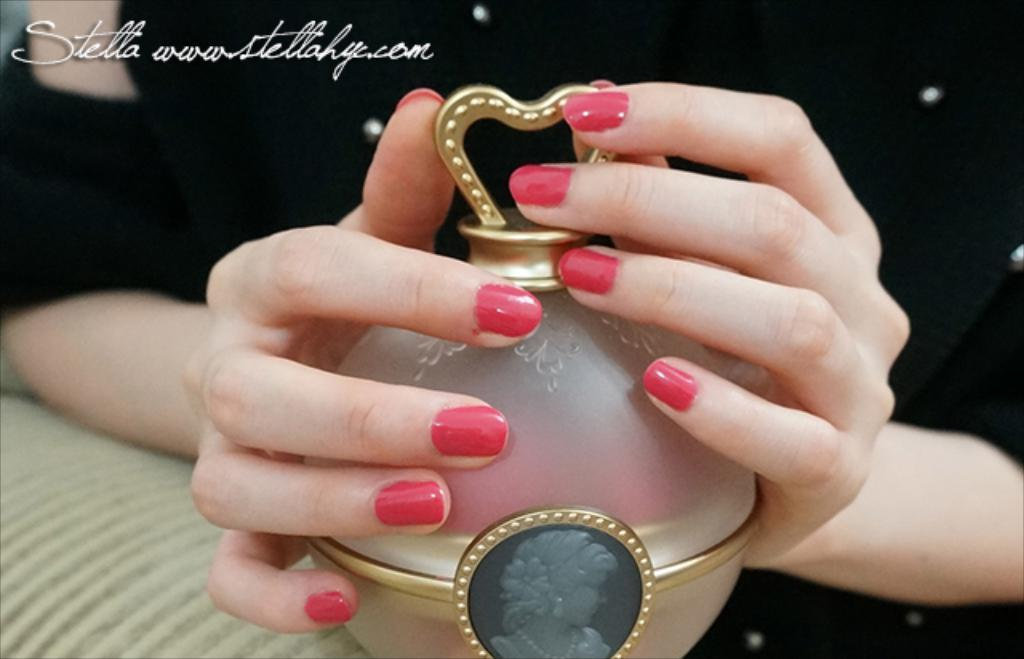<image>
Summarize the visual content of the image. The word Stella near a woman's hands with pink nails. 